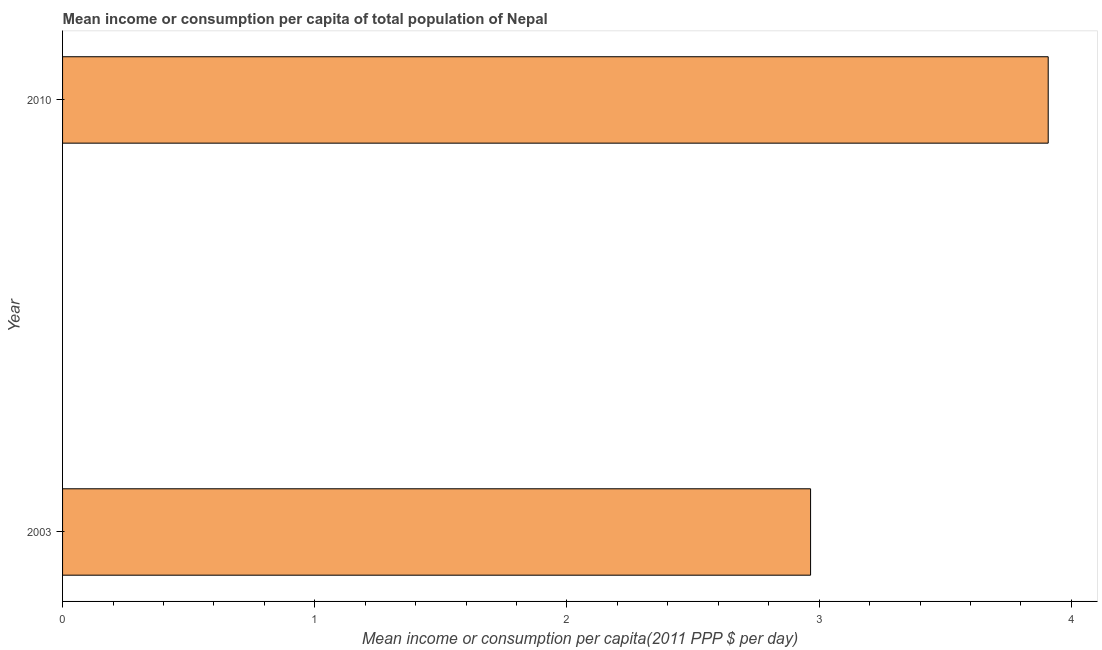What is the title of the graph?
Give a very brief answer. Mean income or consumption per capita of total population of Nepal. What is the label or title of the X-axis?
Provide a short and direct response. Mean income or consumption per capita(2011 PPP $ per day). What is the mean income or consumption in 2003?
Your answer should be very brief. 2.97. Across all years, what is the maximum mean income or consumption?
Make the answer very short. 3.91. Across all years, what is the minimum mean income or consumption?
Offer a terse response. 2.97. What is the sum of the mean income or consumption?
Your answer should be compact. 6.87. What is the difference between the mean income or consumption in 2003 and 2010?
Your answer should be very brief. -0.94. What is the average mean income or consumption per year?
Keep it short and to the point. 3.44. What is the median mean income or consumption?
Offer a very short reply. 3.44. What is the ratio of the mean income or consumption in 2003 to that in 2010?
Your answer should be very brief. 0.76. Are all the bars in the graph horizontal?
Offer a terse response. Yes. What is the difference between two consecutive major ticks on the X-axis?
Your answer should be compact. 1. Are the values on the major ticks of X-axis written in scientific E-notation?
Ensure brevity in your answer.  No. What is the Mean income or consumption per capita(2011 PPP $ per day) in 2003?
Provide a succinct answer. 2.97. What is the Mean income or consumption per capita(2011 PPP $ per day) in 2010?
Give a very brief answer. 3.91. What is the difference between the Mean income or consumption per capita(2011 PPP $ per day) in 2003 and 2010?
Offer a very short reply. -0.94. What is the ratio of the Mean income or consumption per capita(2011 PPP $ per day) in 2003 to that in 2010?
Provide a short and direct response. 0.76. 